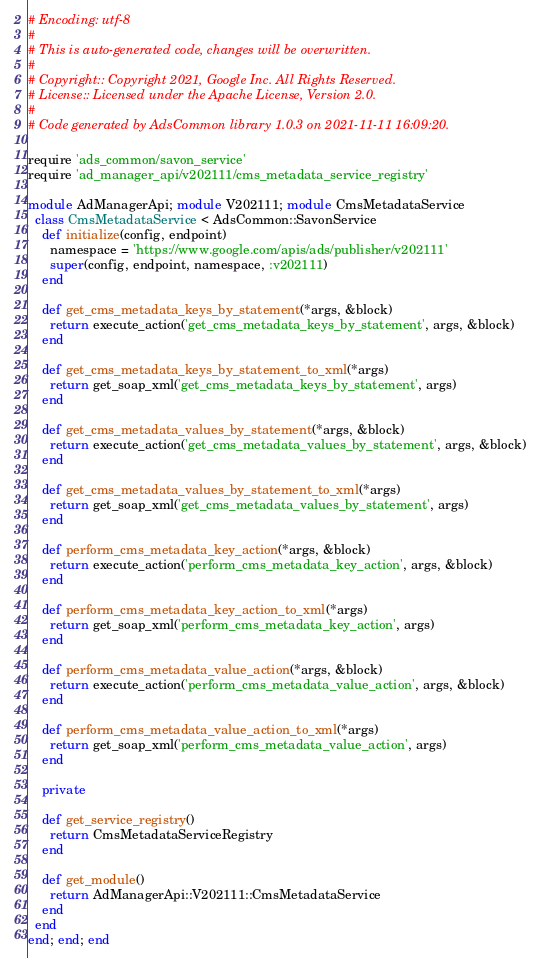Convert code to text. <code><loc_0><loc_0><loc_500><loc_500><_Ruby_># Encoding: utf-8
#
# This is auto-generated code, changes will be overwritten.
#
# Copyright:: Copyright 2021, Google Inc. All Rights Reserved.
# License:: Licensed under the Apache License, Version 2.0.
#
# Code generated by AdsCommon library 1.0.3 on 2021-11-11 16:09:20.

require 'ads_common/savon_service'
require 'ad_manager_api/v202111/cms_metadata_service_registry'

module AdManagerApi; module V202111; module CmsMetadataService
  class CmsMetadataService < AdsCommon::SavonService
    def initialize(config, endpoint)
      namespace = 'https://www.google.com/apis/ads/publisher/v202111'
      super(config, endpoint, namespace, :v202111)
    end

    def get_cms_metadata_keys_by_statement(*args, &block)
      return execute_action('get_cms_metadata_keys_by_statement', args, &block)
    end

    def get_cms_metadata_keys_by_statement_to_xml(*args)
      return get_soap_xml('get_cms_metadata_keys_by_statement', args)
    end

    def get_cms_metadata_values_by_statement(*args, &block)
      return execute_action('get_cms_metadata_values_by_statement', args, &block)
    end

    def get_cms_metadata_values_by_statement_to_xml(*args)
      return get_soap_xml('get_cms_metadata_values_by_statement', args)
    end

    def perform_cms_metadata_key_action(*args, &block)
      return execute_action('perform_cms_metadata_key_action', args, &block)
    end

    def perform_cms_metadata_key_action_to_xml(*args)
      return get_soap_xml('perform_cms_metadata_key_action', args)
    end

    def perform_cms_metadata_value_action(*args, &block)
      return execute_action('perform_cms_metadata_value_action', args, &block)
    end

    def perform_cms_metadata_value_action_to_xml(*args)
      return get_soap_xml('perform_cms_metadata_value_action', args)
    end

    private

    def get_service_registry()
      return CmsMetadataServiceRegistry
    end

    def get_module()
      return AdManagerApi::V202111::CmsMetadataService
    end
  end
end; end; end
</code> 